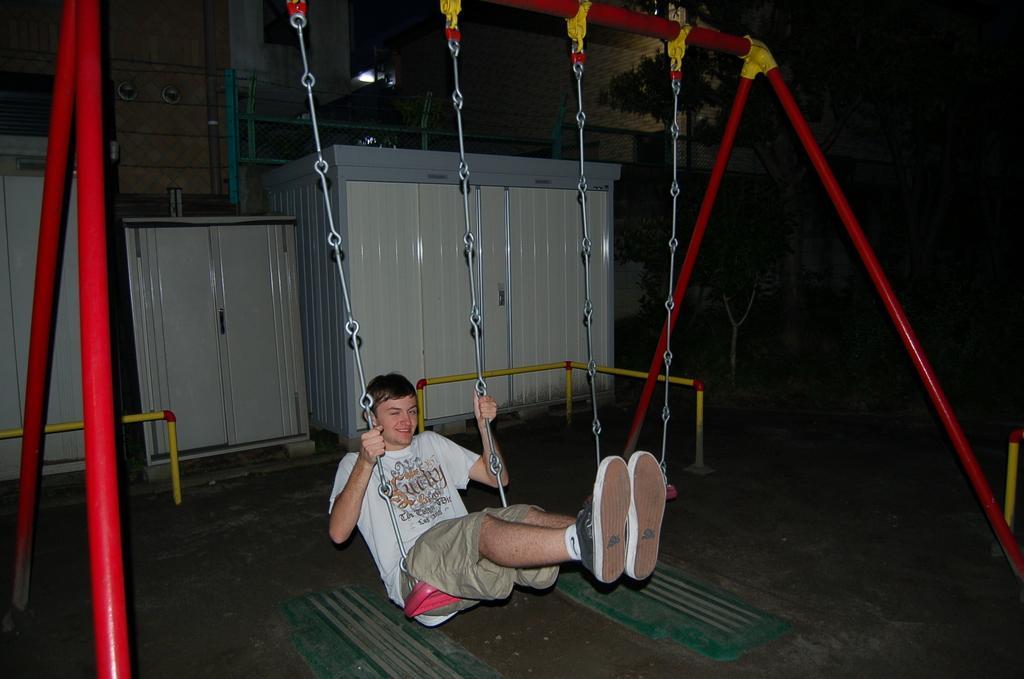Can you describe this image briefly? As we can see in the image there is a man wearing white color t shirt and swinging. In the background there are cupboards. 